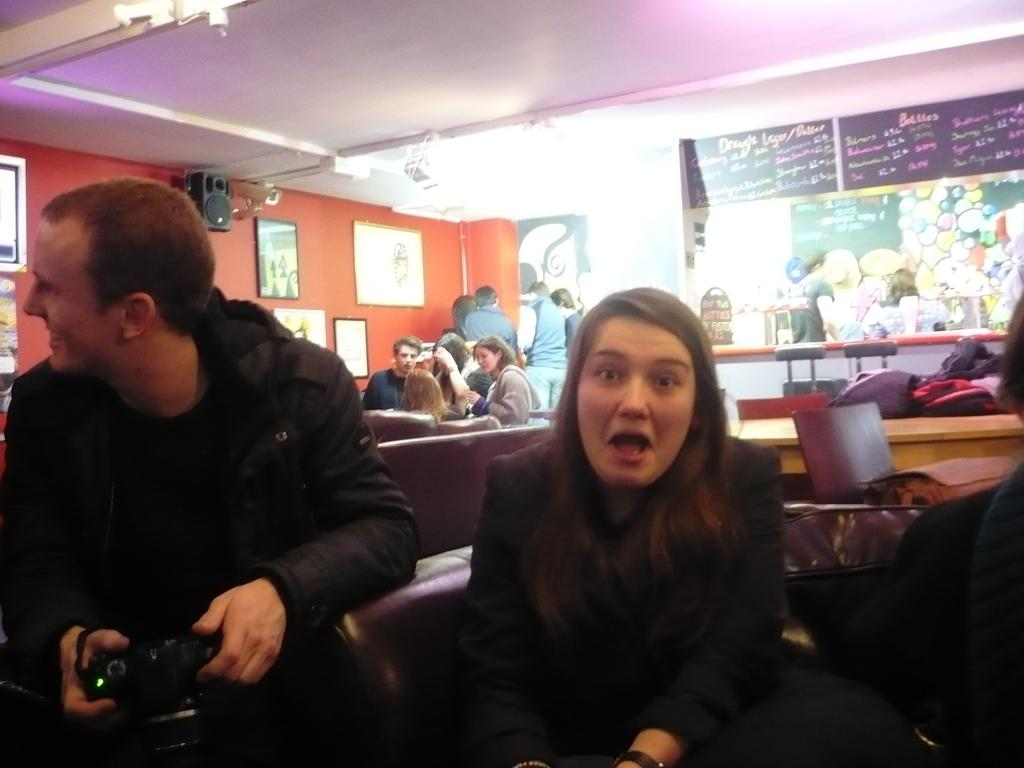What is the man in the image wearing? The man is wearing a black dress in the image. What is the man holding in his hands? The man is holding a camera in his hands. Who is sitting beside the man? There is a girl sitting beside the man. What can be seen behind the man and the girl? There is a group of people behind the man and the girl. What type of bell can be heard ringing in the image? There is no bell present or ringing in the image. What is the color of the copper in the image? There is no copper present in the image. 